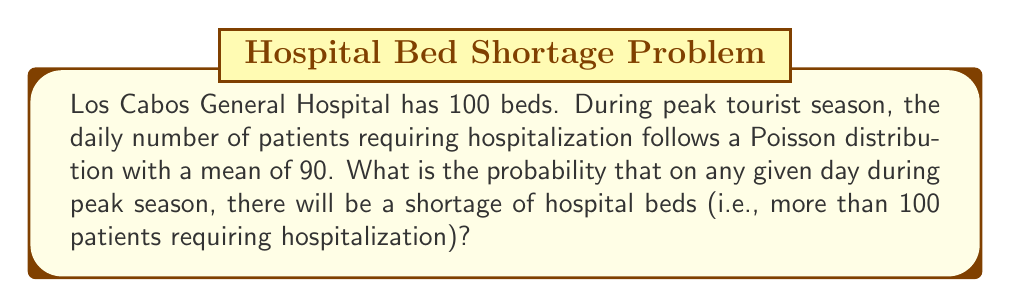Can you answer this question? To solve this problem, we'll follow these steps:

1) The number of patients follows a Poisson distribution with mean $\lambda = 90$.

2) We need to find $P(X > 100)$, where $X$ is the number of patients.

3) This is equivalent to $1 - P(X \leq 100)$.

4) For a Poisson distribution:

   $$P(X = k) = \frac{e^{-\lambda} \lambda^k}{k!}$$

5) We need to calculate:

   $$1 - \sum_{k=0}^{100} \frac{e^{-90} 90^k}{k!}$$

6) This sum is difficult to calculate by hand, so we would typically use statistical software or tables.

7) Using software, we find:

   $$P(X \leq 100) \approx 0.8643$$

8) Therefore:

   $$P(X > 100) = 1 - 0.8643 \approx 0.1357$$

9) Converting to a percentage:

   $$0.1357 \times 100\% \approx 13.57\%$$
Answer: 13.57% 